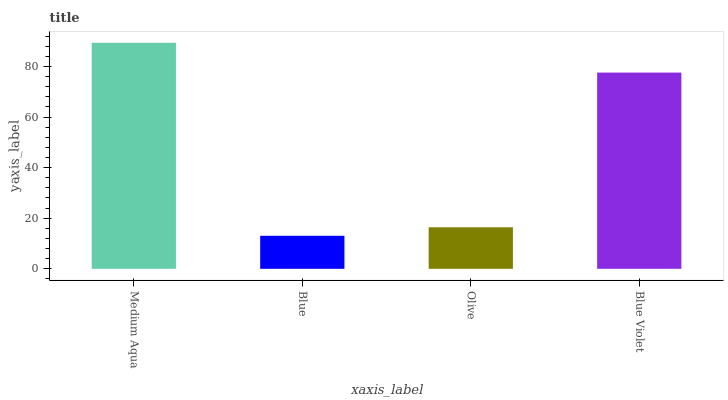Is Blue the minimum?
Answer yes or no. Yes. Is Medium Aqua the maximum?
Answer yes or no. Yes. Is Olive the minimum?
Answer yes or no. No. Is Olive the maximum?
Answer yes or no. No. Is Olive greater than Blue?
Answer yes or no. Yes. Is Blue less than Olive?
Answer yes or no. Yes. Is Blue greater than Olive?
Answer yes or no. No. Is Olive less than Blue?
Answer yes or no. No. Is Blue Violet the high median?
Answer yes or no. Yes. Is Olive the low median?
Answer yes or no. Yes. Is Medium Aqua the high median?
Answer yes or no. No. Is Medium Aqua the low median?
Answer yes or no. No. 